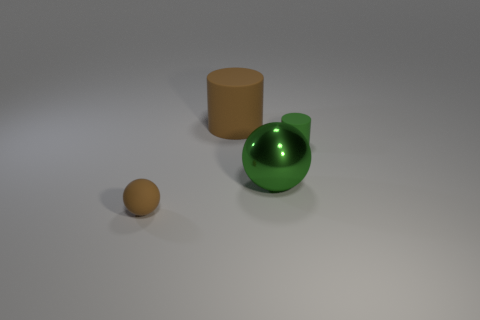What size is the rubber cylinder that is the same color as the large ball?
Provide a short and direct response. Small. There is a object that is the same color as the matte sphere; what is it made of?
Keep it short and to the point. Rubber. There is a tiny rubber object that is on the left side of the ball behind the small brown thing; are there any green metallic things in front of it?
Give a very brief answer. No. What number of other objects are the same material as the green ball?
Your answer should be very brief. 0. How many large brown matte things are there?
Your answer should be very brief. 1. How many objects are blue cylinders or tiny green rubber objects that are right of the large green sphere?
Offer a very short reply. 1. Is there anything else that has the same shape as the metal thing?
Offer a terse response. Yes. There is a green shiny ball that is behind the rubber ball; is its size the same as the green rubber cylinder?
Your response must be concise. No. What number of shiny things are either small gray blocks or large objects?
Offer a very short reply. 1. What size is the rubber cylinder that is right of the large cylinder?
Ensure brevity in your answer.  Small. 